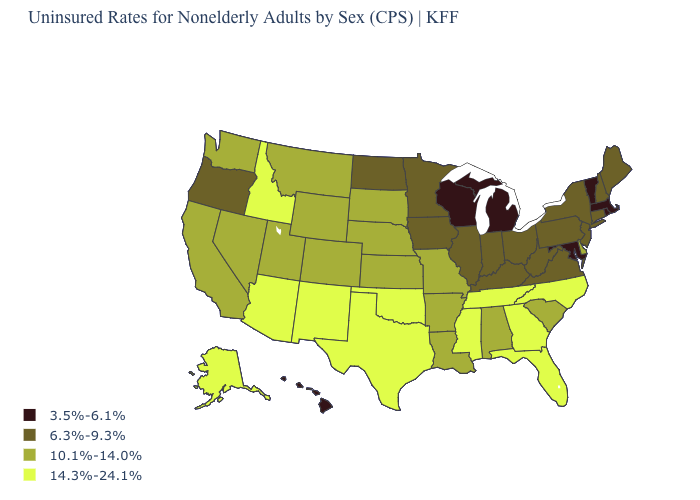Name the states that have a value in the range 14.3%-24.1%?
Give a very brief answer. Alaska, Arizona, Florida, Georgia, Idaho, Mississippi, New Mexico, North Carolina, Oklahoma, Tennessee, Texas. Name the states that have a value in the range 3.5%-6.1%?
Quick response, please. Hawaii, Maryland, Massachusetts, Michigan, Rhode Island, Vermont, Wisconsin. What is the value of Minnesota?
Answer briefly. 6.3%-9.3%. Which states have the highest value in the USA?
Keep it brief. Alaska, Arizona, Florida, Georgia, Idaho, Mississippi, New Mexico, North Carolina, Oklahoma, Tennessee, Texas. What is the lowest value in the USA?
Concise answer only. 3.5%-6.1%. Does the map have missing data?
Short answer required. No. Name the states that have a value in the range 14.3%-24.1%?
Short answer required. Alaska, Arizona, Florida, Georgia, Idaho, Mississippi, New Mexico, North Carolina, Oklahoma, Tennessee, Texas. What is the lowest value in the Northeast?
Quick response, please. 3.5%-6.1%. Name the states that have a value in the range 10.1%-14.0%?
Write a very short answer. Alabama, Arkansas, California, Colorado, Delaware, Kansas, Louisiana, Missouri, Montana, Nebraska, Nevada, South Carolina, South Dakota, Utah, Washington, Wyoming. Does South Carolina have the lowest value in the South?
Write a very short answer. No. How many symbols are there in the legend?
Keep it brief. 4. What is the value of California?
Be succinct. 10.1%-14.0%. Is the legend a continuous bar?
Short answer required. No. Name the states that have a value in the range 3.5%-6.1%?
Give a very brief answer. Hawaii, Maryland, Massachusetts, Michigan, Rhode Island, Vermont, Wisconsin. Which states have the highest value in the USA?
Short answer required. Alaska, Arizona, Florida, Georgia, Idaho, Mississippi, New Mexico, North Carolina, Oklahoma, Tennessee, Texas. 